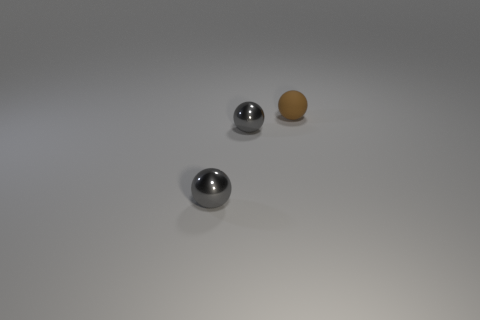How many objects are red objects or gray balls that are on the left side of the matte ball?
Provide a short and direct response. 2. What number of objects are either tiny gray metal balls or large rubber balls?
Keep it short and to the point. 2. Are there any other things that are the same material as the tiny brown ball?
Keep it short and to the point. No. Is there a small metal cube?
Make the answer very short. No. Are there any other gray things that have the same shape as the rubber object?
Ensure brevity in your answer.  Yes. Is the number of gray metallic things behind the brown ball the same as the number of tiny brown matte things?
Your answer should be compact. No. There is a tiny brown object; what shape is it?
Ensure brevity in your answer.  Sphere. Are there more tiny balls that are in front of the small matte thing than tiny yellow matte balls?
Keep it short and to the point. Yes. What number of gray metal objects are the same shape as the small brown matte object?
Provide a succinct answer. 2. Are there any large green balls made of the same material as the brown object?
Offer a terse response. No. 